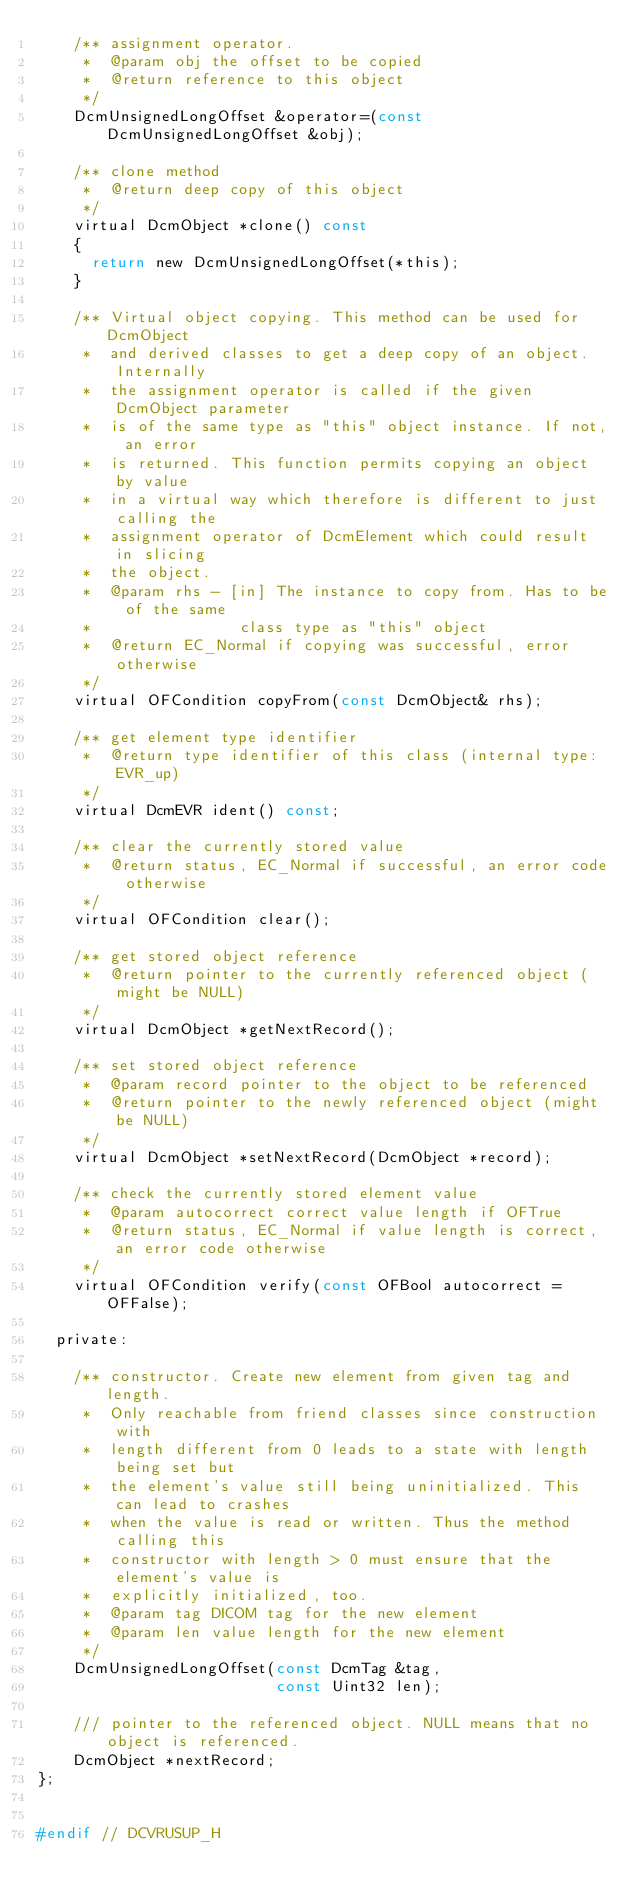Convert code to text. <code><loc_0><loc_0><loc_500><loc_500><_C_>    /** assignment operator.
     *  @param obj the offset to be copied
     *  @return reference to this object
     */
    DcmUnsignedLongOffset &operator=(const DcmUnsignedLongOffset &obj);

    /** clone method
     *  @return deep copy of this object
     */
    virtual DcmObject *clone() const
    {
      return new DcmUnsignedLongOffset(*this);
    }

    /** Virtual object copying. This method can be used for DcmObject
     *  and derived classes to get a deep copy of an object. Internally
     *  the assignment operator is called if the given DcmObject parameter
     *  is of the same type as "this" object instance. If not, an error
     *  is returned. This function permits copying an object by value
     *  in a virtual way which therefore is different to just calling the
     *  assignment operator of DcmElement which could result in slicing
     *  the object.
     *  @param rhs - [in] The instance to copy from. Has to be of the same
     *                class type as "this" object
     *  @return EC_Normal if copying was successful, error otherwise
     */
    virtual OFCondition copyFrom(const DcmObject& rhs);

    /** get element type identifier
     *  @return type identifier of this class (internal type: EVR_up)
     */
    virtual DcmEVR ident() const;

    /** clear the currently stored value
     *  @return status, EC_Normal if successful, an error code otherwise
     */
    virtual OFCondition clear();

    /** get stored object reference
     *  @return pointer to the currently referenced object (might be NULL)
     */
    virtual DcmObject *getNextRecord();

    /** set stored object reference
     *  @param record pointer to the object to be referenced
     *  @return pointer to the newly referenced object (might be NULL)
     */
    virtual DcmObject *setNextRecord(DcmObject *record);

    /** check the currently stored element value
     *  @param autocorrect correct value length if OFTrue
     *  @return status, EC_Normal if value length is correct, an error code otherwise
     */
    virtual OFCondition verify(const OFBool autocorrect = OFFalse);

  private:

    /** constructor. Create new element from given tag and length.
     *  Only reachable from friend classes since construction with
     *  length different from 0 leads to a state with length being set but
     *  the element's value still being uninitialized. This can lead to crashes
     *  when the value is read or written. Thus the method calling this
     *  constructor with length > 0 must ensure that the element's value is
     *  explicitly initialized, too.
     *  @param tag DICOM tag for the new element
     *  @param len value length for the new element
     */
    DcmUnsignedLongOffset(const DcmTag &tag,
                          const Uint32 len);

    /// pointer to the referenced object. NULL means that no object is referenced.
    DcmObject *nextRecord;
};


#endif // DCVRUSUP_H
</code> 